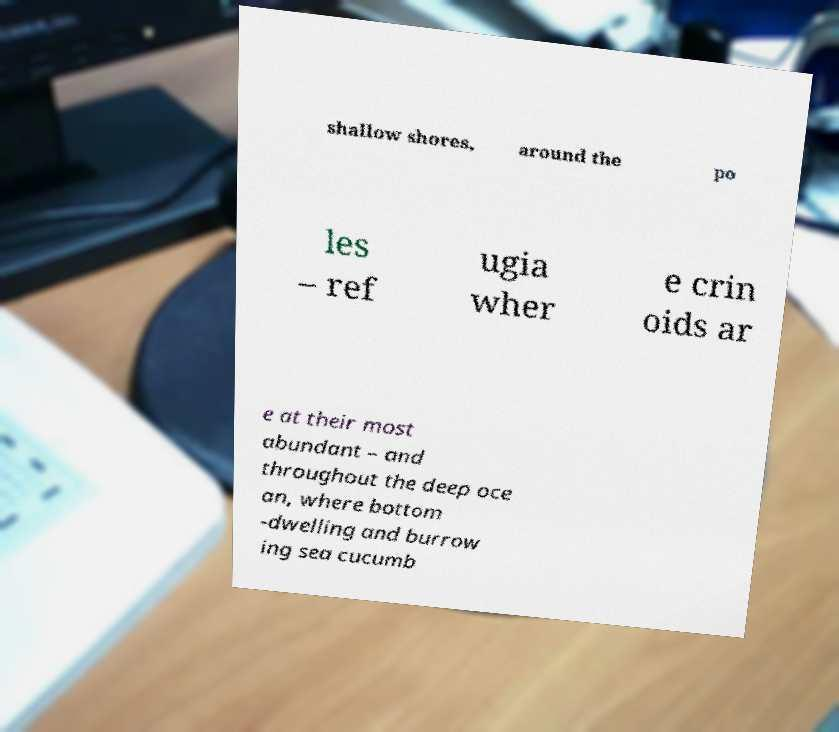Could you extract and type out the text from this image? shallow shores, around the po les – ref ugia wher e crin oids ar e at their most abundant – and throughout the deep oce an, where bottom -dwelling and burrow ing sea cucumb 